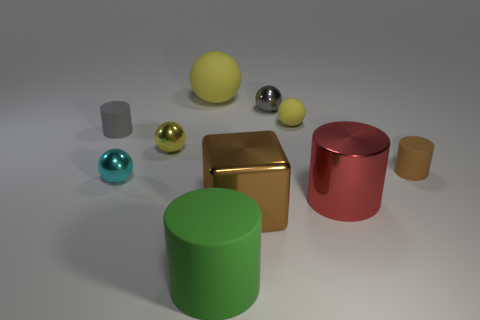Subtract all yellow spheres. How many were subtracted if there are1yellow spheres left? 2 Subtract all large rubber balls. How many balls are left? 4 Subtract all gray cylinders. How many yellow balls are left? 3 Subtract all gray cylinders. How many cylinders are left? 3 Subtract all cylinders. How many objects are left? 6 Add 1 rubber spheres. How many rubber spheres are left? 3 Add 4 small yellow spheres. How many small yellow spheres exist? 6 Subtract 0 purple blocks. How many objects are left? 10 Subtract 2 cylinders. How many cylinders are left? 2 Subtract all gray cubes. Subtract all cyan cylinders. How many cubes are left? 1 